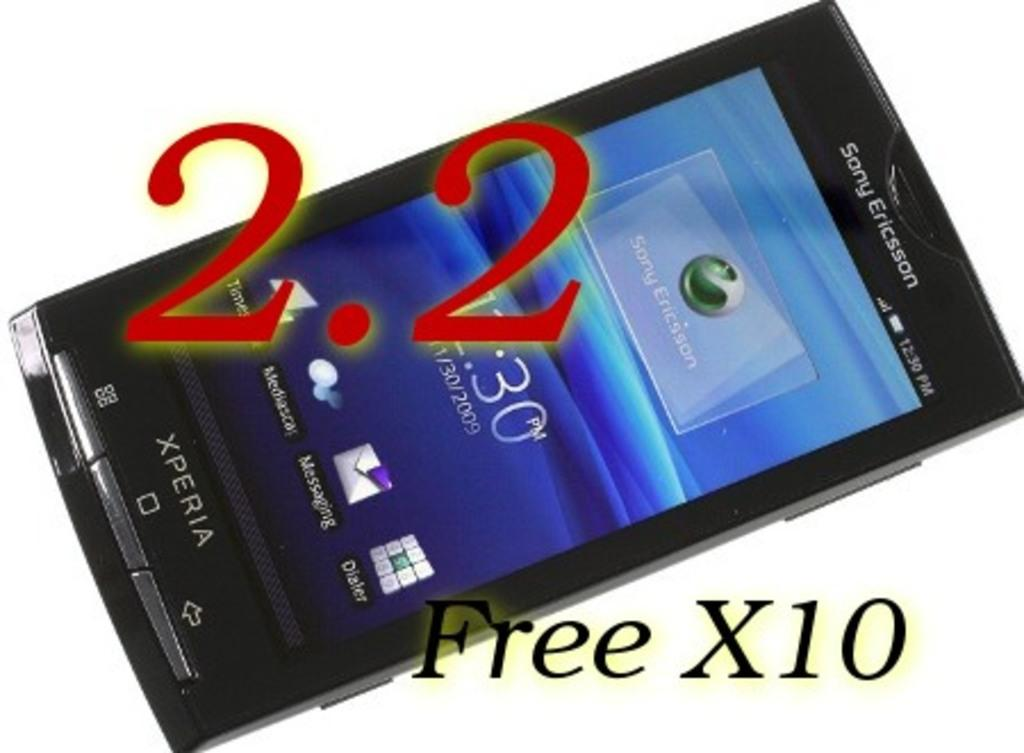<image>
Present a compact description of the photo's key features. an iphone with Free X10 written at the bottom 